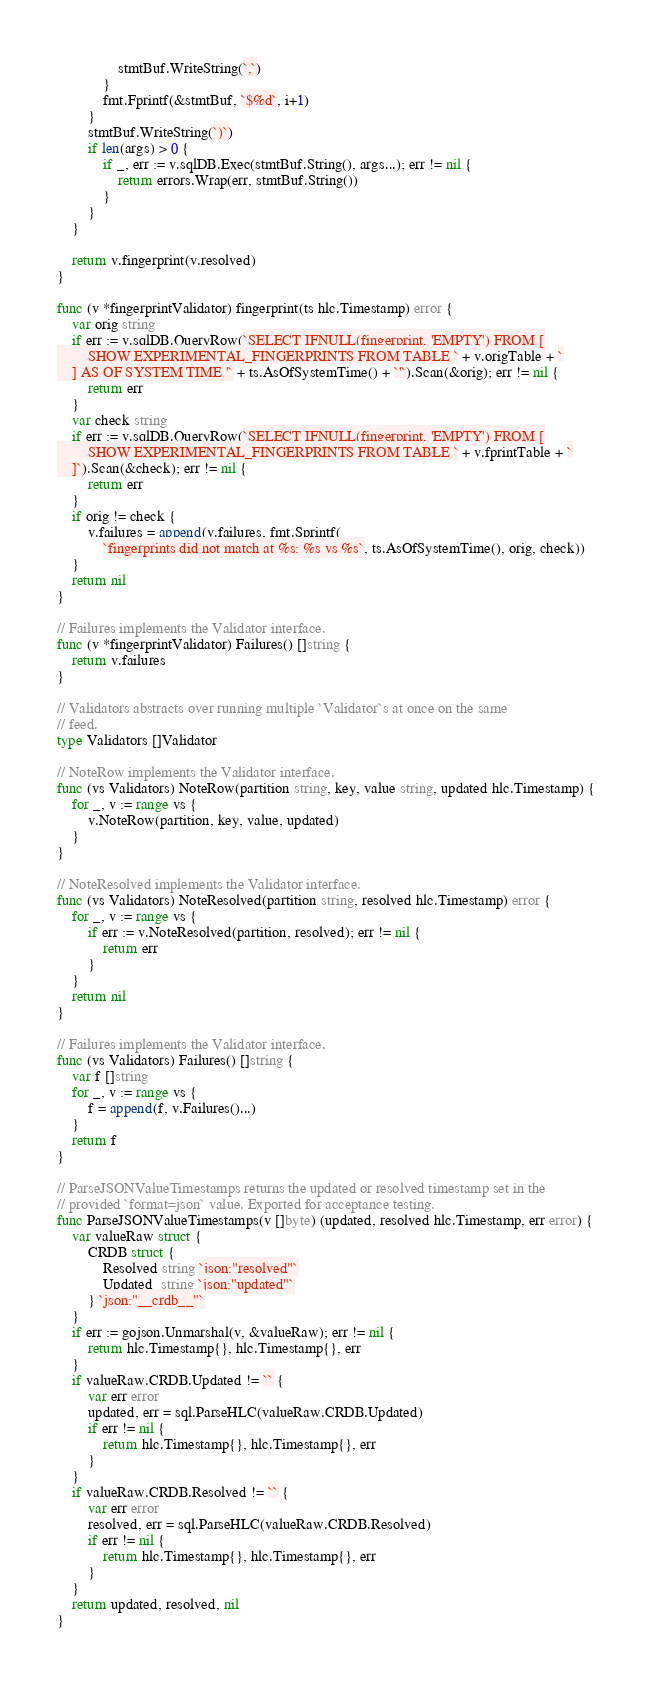<code> <loc_0><loc_0><loc_500><loc_500><_Go_>				stmtBuf.WriteString(`,`)
			}
			fmt.Fprintf(&stmtBuf, `$%d`, i+1)
		}
		stmtBuf.WriteString(`)`)
		if len(args) > 0 {
			if _, err := v.sqlDB.Exec(stmtBuf.String(), args...); err != nil {
				return errors.Wrap(err, stmtBuf.String())
			}
		}
	}

	return v.fingerprint(v.resolved)
}

func (v *fingerprintValidator) fingerprint(ts hlc.Timestamp) error {
	var orig string
	if err := v.sqlDB.QueryRow(`SELECT IFNULL(fingerprint, 'EMPTY') FROM [
		SHOW EXPERIMENTAL_FINGERPRINTS FROM TABLE ` + v.origTable + `
	] AS OF SYSTEM TIME '` + ts.AsOfSystemTime() + `'`).Scan(&orig); err != nil {
		return err
	}
	var check string
	if err := v.sqlDB.QueryRow(`SELECT IFNULL(fingerprint, 'EMPTY') FROM [
		SHOW EXPERIMENTAL_FINGERPRINTS FROM TABLE ` + v.fprintTable + `
	]`).Scan(&check); err != nil {
		return err
	}
	if orig != check {
		v.failures = append(v.failures, fmt.Sprintf(
			`fingerprints did not match at %s: %s vs %s`, ts.AsOfSystemTime(), orig, check))
	}
	return nil
}

// Failures implements the Validator interface.
func (v *fingerprintValidator) Failures() []string {
	return v.failures
}

// Validators abstracts over running multiple `Validator`s at once on the same
// feed.
type Validators []Validator

// NoteRow implements the Validator interface.
func (vs Validators) NoteRow(partition string, key, value string, updated hlc.Timestamp) {
	for _, v := range vs {
		v.NoteRow(partition, key, value, updated)
	}
}

// NoteResolved implements the Validator interface.
func (vs Validators) NoteResolved(partition string, resolved hlc.Timestamp) error {
	for _, v := range vs {
		if err := v.NoteResolved(partition, resolved); err != nil {
			return err
		}
	}
	return nil
}

// Failures implements the Validator interface.
func (vs Validators) Failures() []string {
	var f []string
	for _, v := range vs {
		f = append(f, v.Failures()...)
	}
	return f
}

// ParseJSONValueTimestamps returns the updated or resolved timestamp set in the
// provided `format=json` value. Exported for acceptance testing.
func ParseJSONValueTimestamps(v []byte) (updated, resolved hlc.Timestamp, err error) {
	var valueRaw struct {
		CRDB struct {
			Resolved string `json:"resolved"`
			Updated  string `json:"updated"`
		} `json:"__crdb__"`
	}
	if err := gojson.Unmarshal(v, &valueRaw); err != nil {
		return hlc.Timestamp{}, hlc.Timestamp{}, err
	}
	if valueRaw.CRDB.Updated != `` {
		var err error
		updated, err = sql.ParseHLC(valueRaw.CRDB.Updated)
		if err != nil {
			return hlc.Timestamp{}, hlc.Timestamp{}, err
		}
	}
	if valueRaw.CRDB.Resolved != `` {
		var err error
		resolved, err = sql.ParseHLC(valueRaw.CRDB.Resolved)
		if err != nil {
			return hlc.Timestamp{}, hlc.Timestamp{}, err
		}
	}
	return updated, resolved, nil
}
</code> 